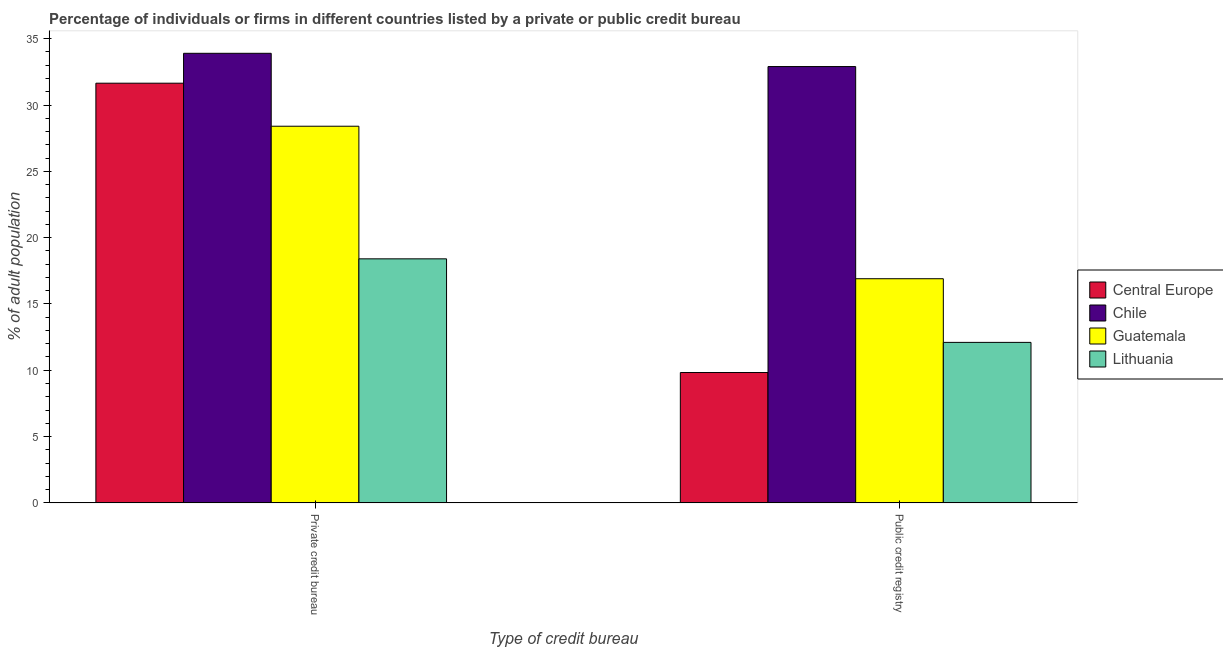How many different coloured bars are there?
Keep it short and to the point. 4. How many bars are there on the 1st tick from the left?
Ensure brevity in your answer.  4. What is the label of the 2nd group of bars from the left?
Your answer should be very brief. Public credit registry. What is the percentage of firms listed by public credit bureau in Central Europe?
Provide a succinct answer. 9.83. Across all countries, what is the maximum percentage of firms listed by private credit bureau?
Make the answer very short. 33.9. Across all countries, what is the minimum percentage of firms listed by public credit bureau?
Ensure brevity in your answer.  9.83. In which country was the percentage of firms listed by public credit bureau maximum?
Make the answer very short. Chile. In which country was the percentage of firms listed by public credit bureau minimum?
Make the answer very short. Central Europe. What is the total percentage of firms listed by public credit bureau in the graph?
Give a very brief answer. 71.73. What is the difference between the percentage of firms listed by public credit bureau in Chile and that in Central Europe?
Provide a succinct answer. 23.07. What is the average percentage of firms listed by public credit bureau per country?
Provide a succinct answer. 17.93. In how many countries, is the percentage of firms listed by public credit bureau greater than 23 %?
Your answer should be very brief. 1. What is the ratio of the percentage of firms listed by public credit bureau in Lithuania to that in Central Europe?
Make the answer very short. 1.23. Is the percentage of firms listed by private credit bureau in Chile less than that in Guatemala?
Ensure brevity in your answer.  No. In how many countries, is the percentage of firms listed by public credit bureau greater than the average percentage of firms listed by public credit bureau taken over all countries?
Your answer should be very brief. 1. What does the 3rd bar from the left in Public credit registry represents?
Give a very brief answer. Guatemala. What does the 3rd bar from the right in Public credit registry represents?
Ensure brevity in your answer.  Chile. Are all the bars in the graph horizontal?
Provide a short and direct response. No. What is the difference between two consecutive major ticks on the Y-axis?
Ensure brevity in your answer.  5. Does the graph contain any zero values?
Ensure brevity in your answer.  No. Does the graph contain grids?
Make the answer very short. No. How many legend labels are there?
Give a very brief answer. 4. How are the legend labels stacked?
Provide a short and direct response. Vertical. What is the title of the graph?
Your answer should be compact. Percentage of individuals or firms in different countries listed by a private or public credit bureau. Does "Germany" appear as one of the legend labels in the graph?
Offer a terse response. No. What is the label or title of the X-axis?
Provide a succinct answer. Type of credit bureau. What is the label or title of the Y-axis?
Your answer should be compact. % of adult population. What is the % of adult population in Central Europe in Private credit bureau?
Your response must be concise. 31.65. What is the % of adult population of Chile in Private credit bureau?
Your answer should be very brief. 33.9. What is the % of adult population of Guatemala in Private credit bureau?
Keep it short and to the point. 28.4. What is the % of adult population in Central Europe in Public credit registry?
Provide a succinct answer. 9.83. What is the % of adult population in Chile in Public credit registry?
Offer a very short reply. 32.9. Across all Type of credit bureau, what is the maximum % of adult population of Central Europe?
Make the answer very short. 31.65. Across all Type of credit bureau, what is the maximum % of adult population in Chile?
Offer a very short reply. 33.9. Across all Type of credit bureau, what is the maximum % of adult population of Guatemala?
Offer a very short reply. 28.4. Across all Type of credit bureau, what is the minimum % of adult population in Central Europe?
Offer a very short reply. 9.83. Across all Type of credit bureau, what is the minimum % of adult population of Chile?
Offer a terse response. 32.9. Across all Type of credit bureau, what is the minimum % of adult population in Guatemala?
Your answer should be compact. 16.9. What is the total % of adult population of Central Europe in the graph?
Your response must be concise. 41.47. What is the total % of adult population in Chile in the graph?
Your answer should be very brief. 66.8. What is the total % of adult population in Guatemala in the graph?
Give a very brief answer. 45.3. What is the total % of adult population in Lithuania in the graph?
Ensure brevity in your answer.  30.5. What is the difference between the % of adult population of Central Europe in Private credit bureau and that in Public credit registry?
Provide a short and direct response. 21.82. What is the difference between the % of adult population in Chile in Private credit bureau and that in Public credit registry?
Your answer should be very brief. 1. What is the difference between the % of adult population of Guatemala in Private credit bureau and that in Public credit registry?
Your response must be concise. 11.5. What is the difference between the % of adult population in Lithuania in Private credit bureau and that in Public credit registry?
Keep it short and to the point. 6.3. What is the difference between the % of adult population in Central Europe in Private credit bureau and the % of adult population in Chile in Public credit registry?
Provide a succinct answer. -1.25. What is the difference between the % of adult population in Central Europe in Private credit bureau and the % of adult population in Guatemala in Public credit registry?
Keep it short and to the point. 14.75. What is the difference between the % of adult population in Central Europe in Private credit bureau and the % of adult population in Lithuania in Public credit registry?
Provide a short and direct response. 19.55. What is the difference between the % of adult population in Chile in Private credit bureau and the % of adult population in Lithuania in Public credit registry?
Give a very brief answer. 21.8. What is the average % of adult population of Central Europe per Type of credit bureau?
Give a very brief answer. 20.74. What is the average % of adult population in Chile per Type of credit bureau?
Your answer should be very brief. 33.4. What is the average % of adult population in Guatemala per Type of credit bureau?
Keep it short and to the point. 22.65. What is the average % of adult population of Lithuania per Type of credit bureau?
Offer a very short reply. 15.25. What is the difference between the % of adult population in Central Europe and % of adult population in Chile in Private credit bureau?
Ensure brevity in your answer.  -2.25. What is the difference between the % of adult population in Central Europe and % of adult population in Guatemala in Private credit bureau?
Your response must be concise. 3.25. What is the difference between the % of adult population of Central Europe and % of adult population of Lithuania in Private credit bureau?
Give a very brief answer. 13.25. What is the difference between the % of adult population in Guatemala and % of adult population in Lithuania in Private credit bureau?
Offer a terse response. 10. What is the difference between the % of adult population of Central Europe and % of adult population of Chile in Public credit registry?
Ensure brevity in your answer.  -23.07. What is the difference between the % of adult population in Central Europe and % of adult population in Guatemala in Public credit registry?
Your answer should be very brief. -7.07. What is the difference between the % of adult population of Central Europe and % of adult population of Lithuania in Public credit registry?
Make the answer very short. -2.27. What is the difference between the % of adult population of Chile and % of adult population of Guatemala in Public credit registry?
Make the answer very short. 16. What is the difference between the % of adult population in Chile and % of adult population in Lithuania in Public credit registry?
Your answer should be compact. 20.8. What is the difference between the % of adult population in Guatemala and % of adult population in Lithuania in Public credit registry?
Offer a very short reply. 4.8. What is the ratio of the % of adult population of Central Europe in Private credit bureau to that in Public credit registry?
Give a very brief answer. 3.22. What is the ratio of the % of adult population of Chile in Private credit bureau to that in Public credit registry?
Keep it short and to the point. 1.03. What is the ratio of the % of adult population of Guatemala in Private credit bureau to that in Public credit registry?
Provide a short and direct response. 1.68. What is the ratio of the % of adult population in Lithuania in Private credit bureau to that in Public credit registry?
Ensure brevity in your answer.  1.52. What is the difference between the highest and the second highest % of adult population of Central Europe?
Give a very brief answer. 21.82. What is the difference between the highest and the second highest % of adult population of Guatemala?
Your answer should be compact. 11.5. What is the difference between the highest and the lowest % of adult population of Central Europe?
Your answer should be compact. 21.82. What is the difference between the highest and the lowest % of adult population in Chile?
Make the answer very short. 1. 